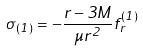Convert formula to latex. <formula><loc_0><loc_0><loc_500><loc_500>\sigma _ { ( 1 ) } = - \frac { r - 3 M } { \mu r ^ { 2 } } f ^ { ( 1 ) } _ { r }</formula> 